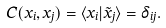<formula> <loc_0><loc_0><loc_500><loc_500>C ( x _ { i } , x _ { j } ) = \langle x _ { i } | \tilde { x } _ { j } \rangle = \delta _ { i j } .</formula> 